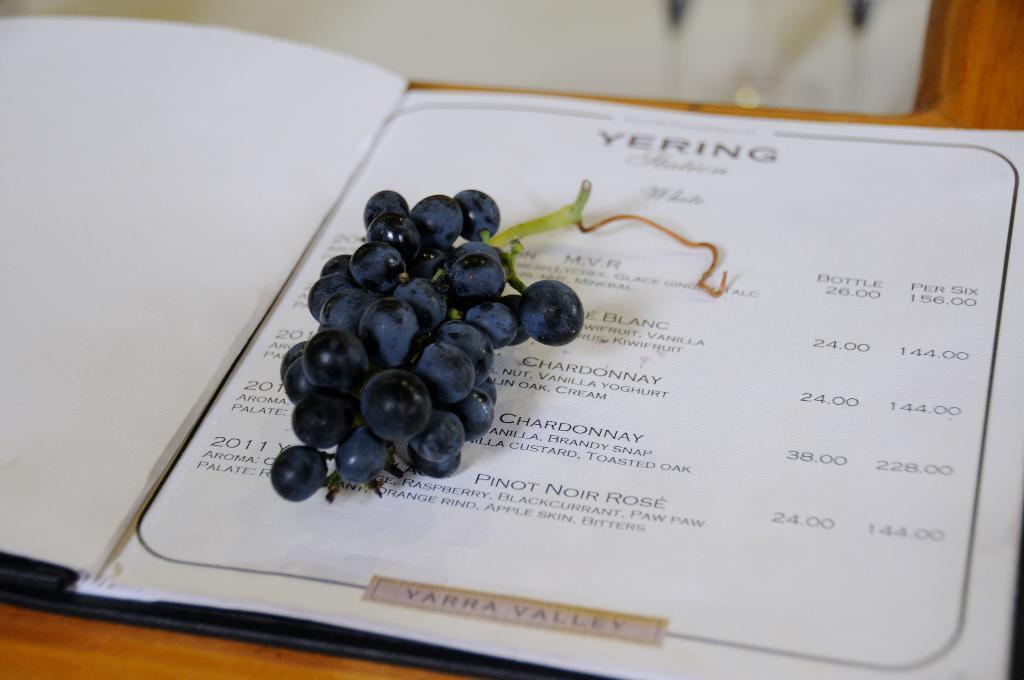How would you summarize this image in a sentence or two? This picture shows a menu card on the table and we see bunch of grapes on it. 